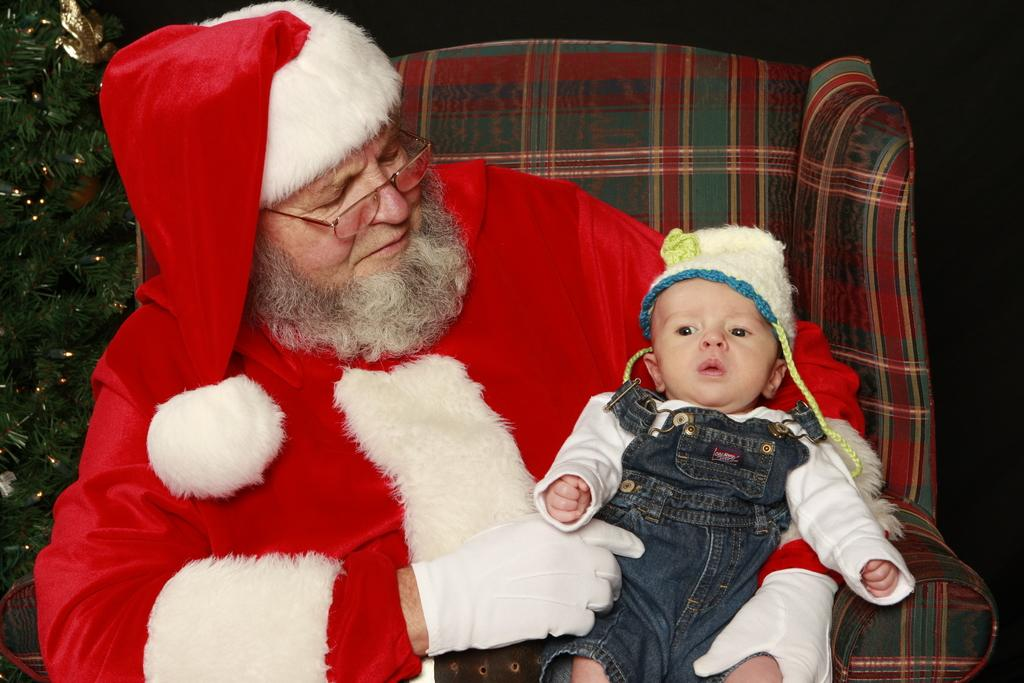Who is the main subject in the image? There is a man in the image. What is the man dressed as? The man is dressed as Santa Claus. What is the man doing in the image? The man is sitting on a chair and holding a baby. What can be seen in the background of the image? There is a decorated tree in the image, which is partially visible beside the man. What thought does the man have about the bag in the image? There is no mention of a bag in the image, so it is impossible to determine any thoughts the man might have about a bag. 